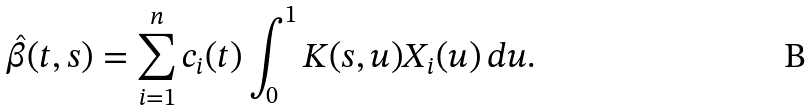Convert formula to latex. <formula><loc_0><loc_0><loc_500><loc_500>\hat { \beta } ( t , s ) = \sum _ { i = 1 } ^ { n } c _ { i } ( t ) \int _ { 0 } ^ { 1 } K ( s , u ) X _ { i } ( u ) \, d u .</formula> 